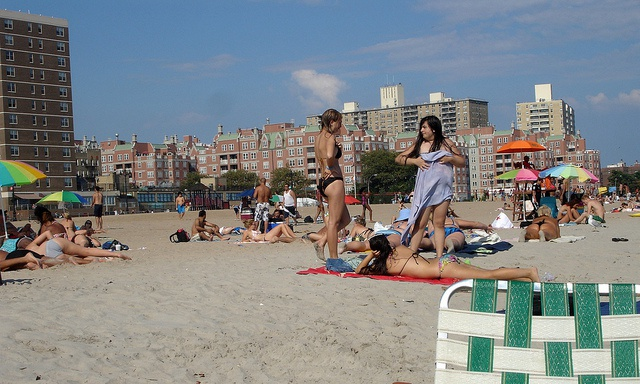Describe the objects in this image and their specific colors. I can see chair in gray, lightgray, teal, and darkgray tones, people in gray, black, darkgray, and tan tones, people in gray, darkgray, and black tones, people in gray, tan, and black tones, and people in gray, black, maroon, and tan tones in this image. 